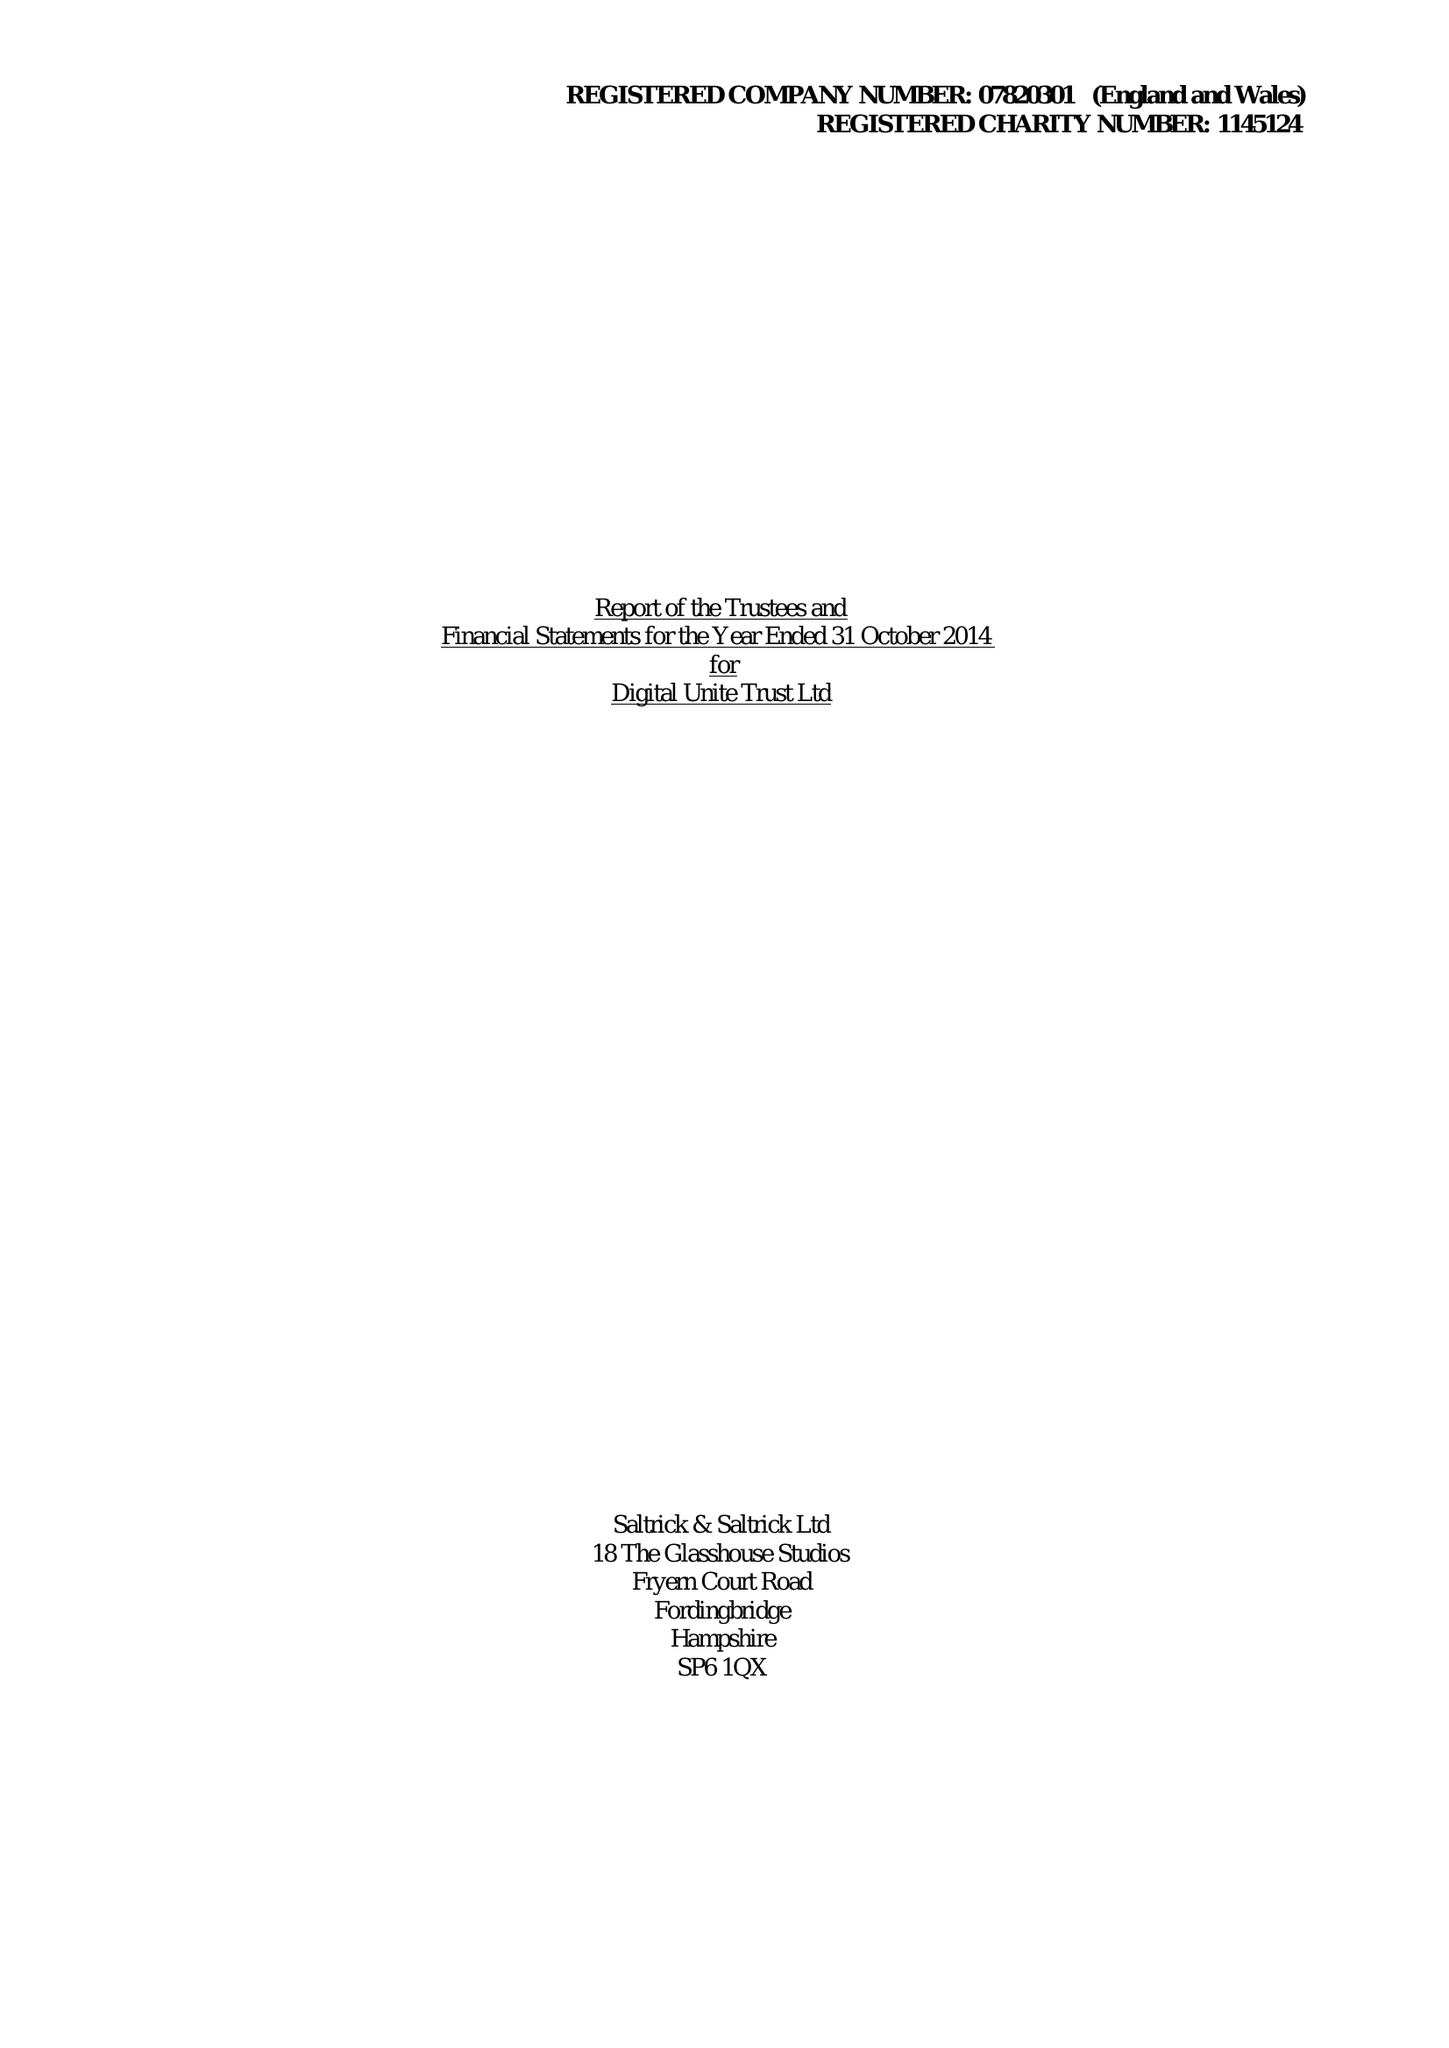What is the value for the address__postcode?
Answer the question using a single word or phrase. PO17 6JB 